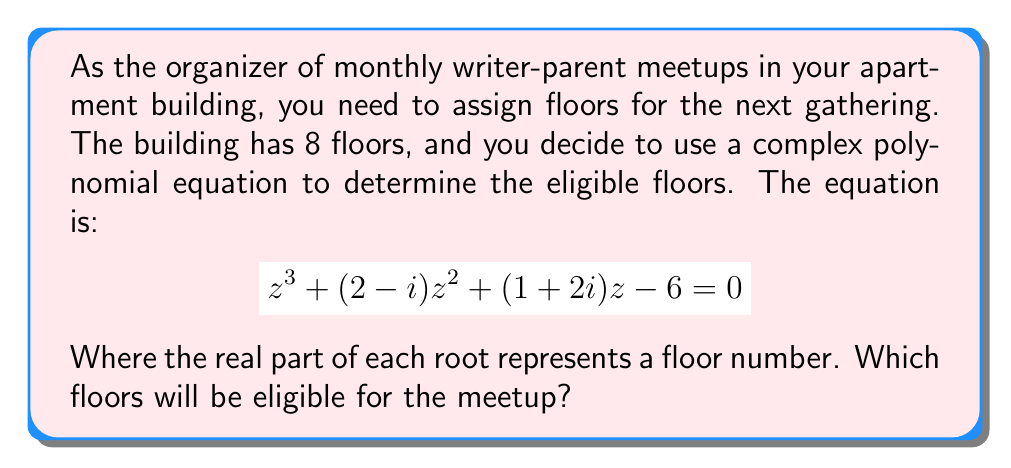Give your solution to this math problem. To solve this, we need to find the roots of the given complex polynomial equation:

1) First, we can use the rational root theorem to find one real root. The possible rational roots are the factors of the constant term: ±1, ±2, ±3, ±6.

2) Testing these values, we find that z = 1 is a root.

3) Now we can factor out (z - 1) from the original equation:

   $$(z - 1)(z^2 + (3-i)z + 6) = 0$$

4) We can solve the quadratic equation $z^2 + (3-i)z + 6 = 0$ using the quadratic formula:

   $$z = \frac{-(3-i) \pm \sqrt{(3-i)^2 - 4(6)}}{2}$$

5) Simplifying:
   
   $$z = \frac{-(3-i) \pm \sqrt{9-6i+i^2 - 24}}{2}$$
   $$z = \frac{-(3-i) \pm \sqrt{-16-6i}}{2}$$
   $$z = \frac{-(3-i) \pm (2\sqrt{2}-i\sqrt{2})}{2}$$

6) This gives us two more roots:

   $$z = -\frac{3}{2} + \frac{i}{2} + \sqrt{2} - \frac{i}{\sqrt{2}} = -\frac{3}{2} + \sqrt{2} + i(\frac{1}{2} - \frac{1}{\sqrt{2}})$$
   $$z = -\frac{3}{2} + \frac{i}{2} - \sqrt{2} + \frac{i}{\sqrt{2}} = -\frac{3}{2} - \sqrt{2} + i(\frac{1}{2} + \frac{1}{\sqrt{2}})$$

7) The real parts of these roots are 1, -1.5 + √2 ≈ -0.09, and -1.5 - √2 ≈ -2.91.

8) Rounding to the nearest integer (as floor numbers are integers), we get 1, 0, and -3.

9) Since the building has 8 floors, we can only use the positive root, which is 1.
Answer: The 1st floor 